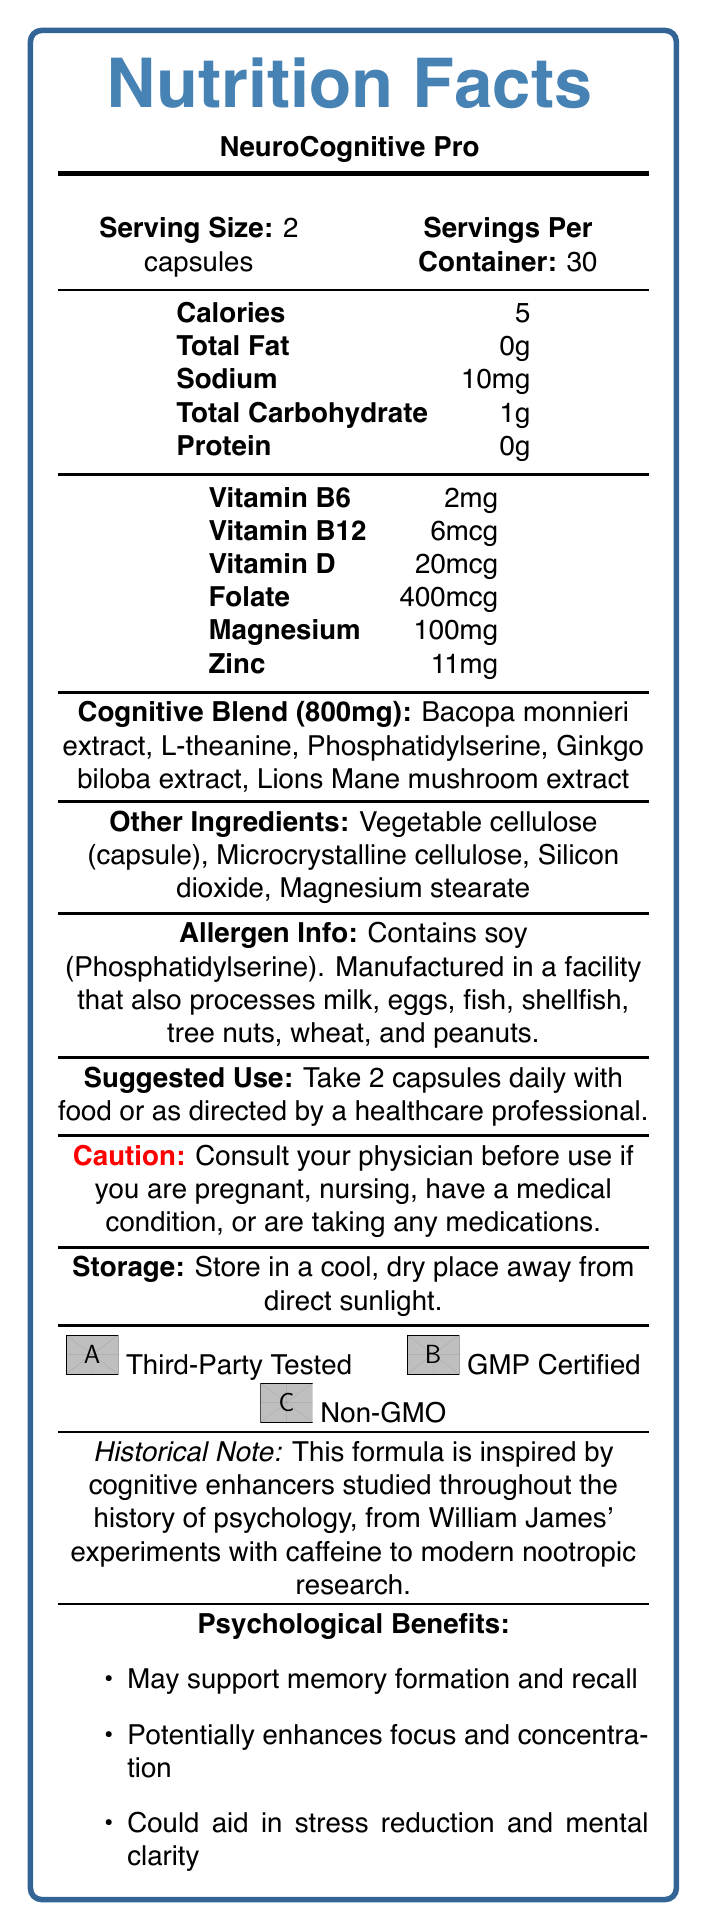what is the serving size? The document states that the serving size is 2 capsules.
Answer: 2 capsules how many servings are there per container? The document clearly mentions that there are 30 servings per container.
Answer: 30 how many calories are in one serving? The document lists that each serving contains 5 calories.
Answer: 5 what is the amount of sodium per serving? According to the document, each serving contains 10mg of sodium.
Answer: 10mg which vitamins are present in the supplement? The document specifies the presence of Vitamin B6, Vitamin B12, Vitamin D, and Folate in the supplement.
Answer: Vitamin B6, Vitamin B12, Vitamin D, Folate what is the total amount of the cognitive blend per serving? The document mentions the total amount of the cognitive blend is 800mg per serving.
Answer: 800mg what are three ingredients in the cognitive blend? The cognitive blend includes Bacopa monnieri extract, L-theanine, and Phosphatidylserine, as listed in the document.
Answer: Bacopa monnieri extract, L-theanine, Phosphatidylserine what are two other ingredients found in the capsules? The document lists Vegetable cellulose (capsule) and Microcrystalline cellulose among the other ingredients.
Answer: Vegetable cellulose (capsule), Microcrystalline cellulose is the supplement manufactured in a facility that also processes peanuts? The allergen info section indicates that the supplement is manufactured in a facility that processes peanuts among other allergens.
Answer: Yes does the product contain any protein? The document lists 0g of protein per serving.
Answer: No Select the allergen contained in the supplement:
1. Soy
2. Milk
3. Wheat
4. Peanuts The document states that the supplement contains soy.
Answer: 1. Soy which ingredient is not present in the product's cognitive blend?
A. Bacopa monnieri extract
B. L-theanine
C. Zinc
D. Ginkgo biloba extract Zinc is not part of the cognitive blend but is listed under the individual nutrient amounts.
Answer: C. Zinc Can the document determine whether the suggestion to use the supplement should be tailored to individual health needs? The document advises consulting a physician if pregnant, nursing, or having medical conditions, but it doesn’t specify tailored individual health needs beyond general caution.
Answer: No, cannot be determined Is the supplement vegan? The document states that the supplement is not vegan.
Answer: No Summarize the main idea of the document. The document contains comprehensive information about NeuroCognitive Pro, including its nutritional value, ingredients, suggested use, cautions, and benefits related to cognitive enhancement, framed within the context of psychological research and history.
Answer: The document is a nutrition facts label for a brain-boosting supplement called NeuroCognitive Pro, detailing serving sizes, nutritional content, ingredients including a cognitive blend, allergen information, usage suggestions, storage instructions, and certifications. It highlights psychological benefits and provides a historical context for the formulation. 